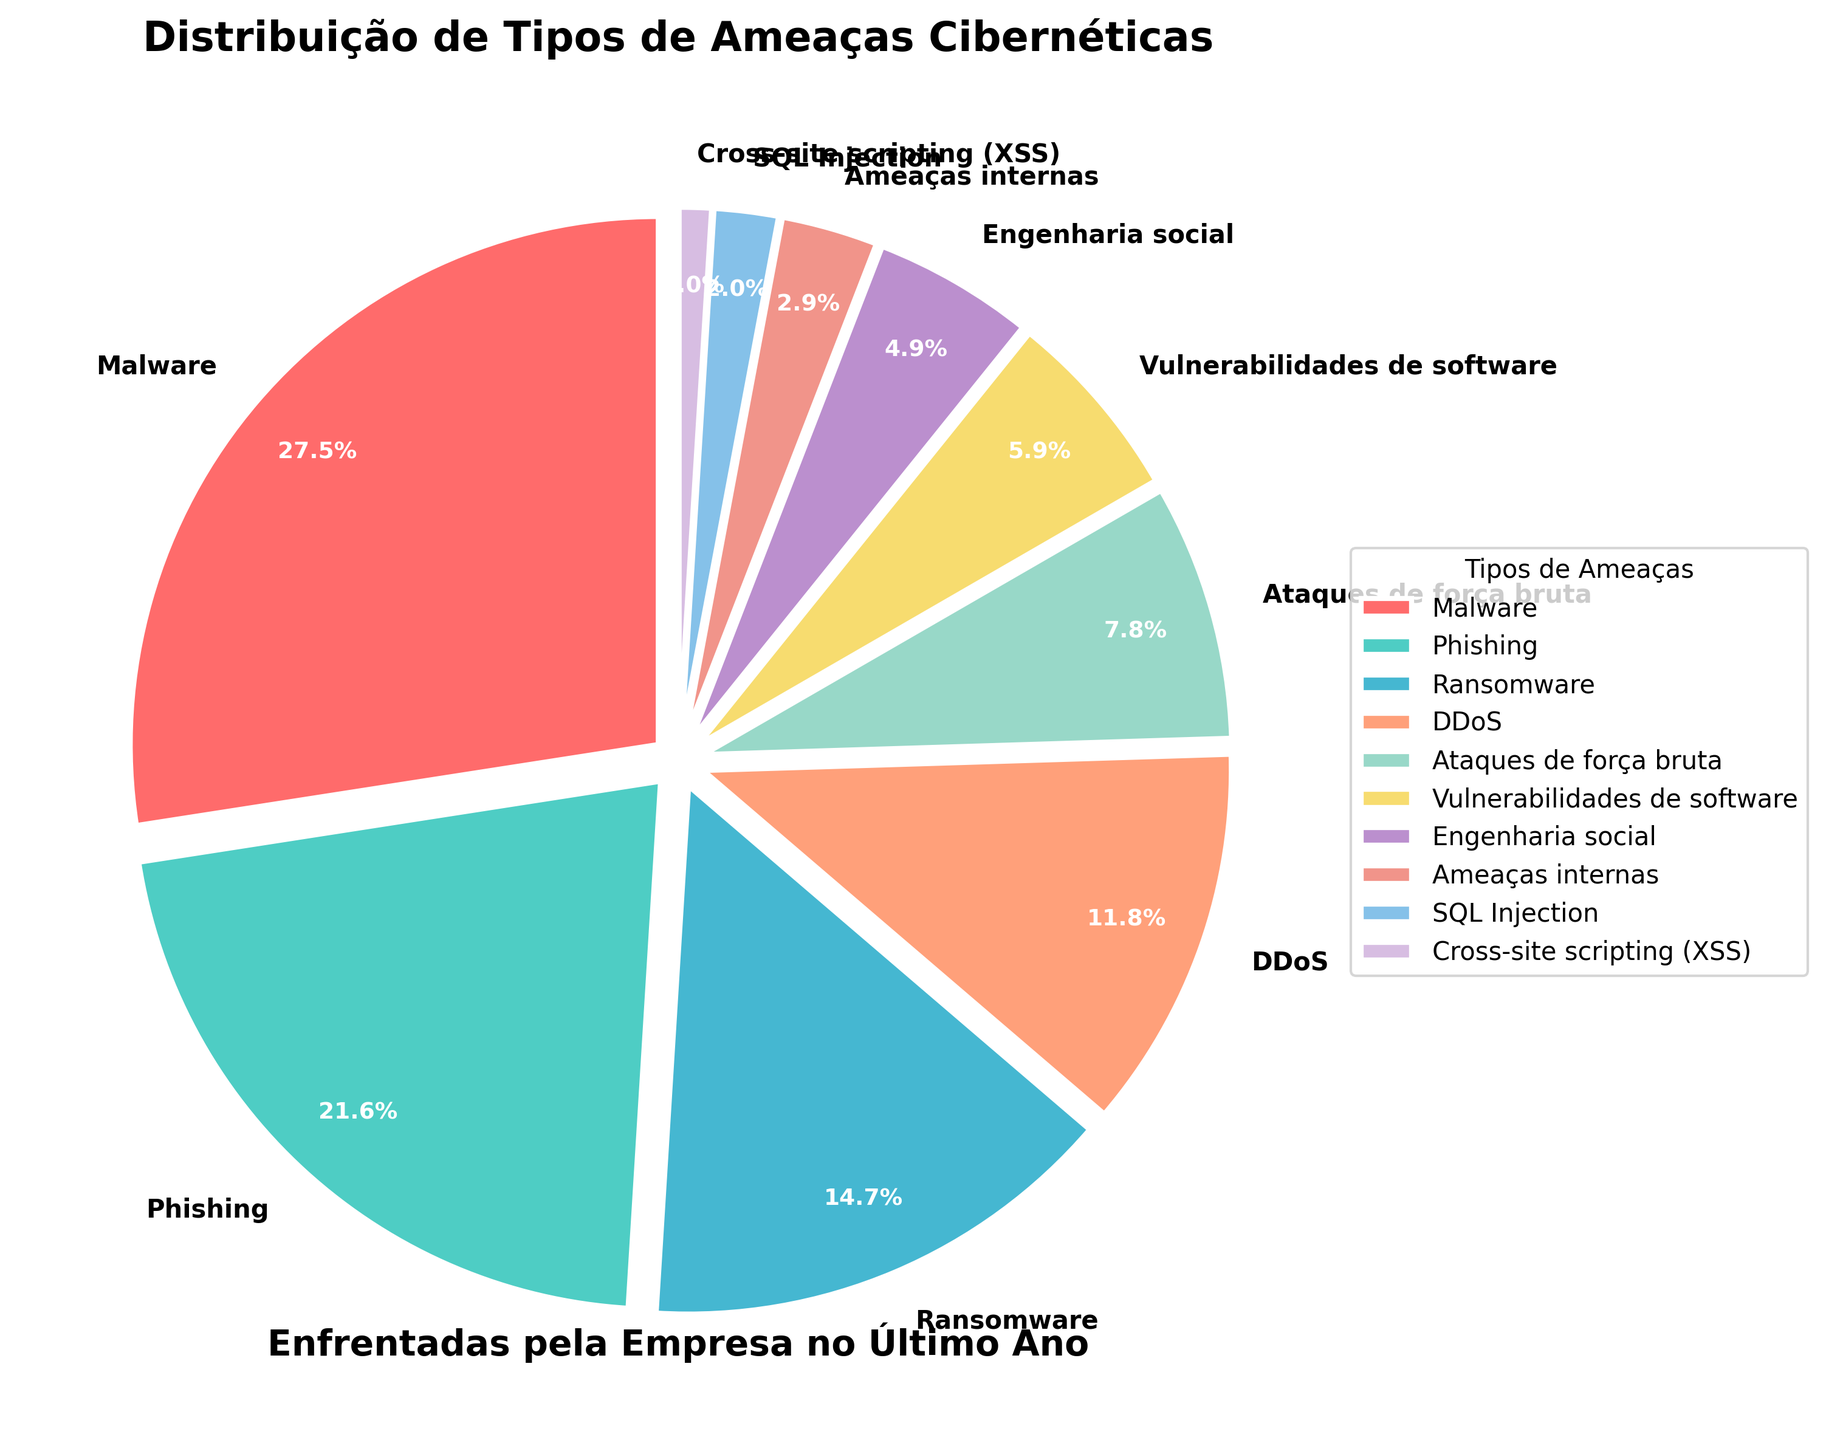Qual é o tipo de ameaça cibernética mais frequente enfrentada pela empresa no último ano? O tipo de ameaça cibernética com a maior porcentagem no gráfico de pizza é o mais frequente. Observamos que 'Malware' tem a maior fatia, com 28%.
Answer: Malware Qual é o percentual combinado de Phishing e Ransomware enfrentados pela empresa? Some as porcentagens de Phishing (22%) e Ransomware (15%). 22 + 15 = 37%.
Answer: 37% Qual ameaça tem uma porcentagem menor: Engenharia Social ou Ameaças Internas? Compare as porcentagens de Engenharia Social (5%) e Ameaças Internas (3%) e identifique qual é menor.
Answer: Ameaças Internas Quantos tipos de ameaças têm uma porcentagem maior do que 10%? Conte os tipos de ameaças cujas porcentagens são maiores que 10%. Elas são: Malware (28%), Phishing (22%), Ransomware (15%) e DDoS (12%). No total, há 4 tipos.
Answer: 4 Quais tipos de ameaças representam juntos menos de 10% das ameaças enfrentadas? Identifique os tipos de ameaças cujas porcentagens individuais são menores que 10%. São eles: Ameaças Internas (3%), SQL Injection (2%) e Cross-site scripting (XSS) (1%).
Answer: Ameaças Internas, SQL Injection, Cross-site scripting (XSS) Qual a diferença percentual entre Malware e DDoS? Subtraia a porcentagem de DDoS (12%) da porcentagem de Malware (28%). 28 - 12 = 16%.
Answer: 16% Quantos tipos de ameaças têm uma porcentagem exata de 8%? Verifique o gráfico e conte quantas ameaças têm uma porcentagem de 8%. Apenas uma ameaça se encaixa nesse critério: Ataques de força bruta.
Answer: 1 Qual a cor representada na área que representa Vulnerabilidades de Software? Observe a colorização do gráfico de pizza e identifique a cor correspondente a Vulnerabilidades de Software (na legenda ou no gráfico). A cor é amarelo.
Answer: Amarelo Quais são as duas ameaças menos frequentes enfrentadas pela empresa? Identifique as duas fatias menores no gráfico de pizza. Aquelas são: SQL Injection (2%) e Cross-site scripting (XSS) (1%).
Answer: SQL Injection, Cross-site scripting (XSS) Qual é a diferença entre o percentual de Engenharia Social e ataques de força bruta? Subtraia a porcentagem de Engenharia Social (5%) pela porcentagem de Ataques de força bruta (8%). A diferença é 8 - 5 = 3%.
Answer: 3% 